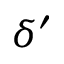Convert formula to latex. <formula><loc_0><loc_0><loc_500><loc_500>\delta ^ { \prime }</formula> 